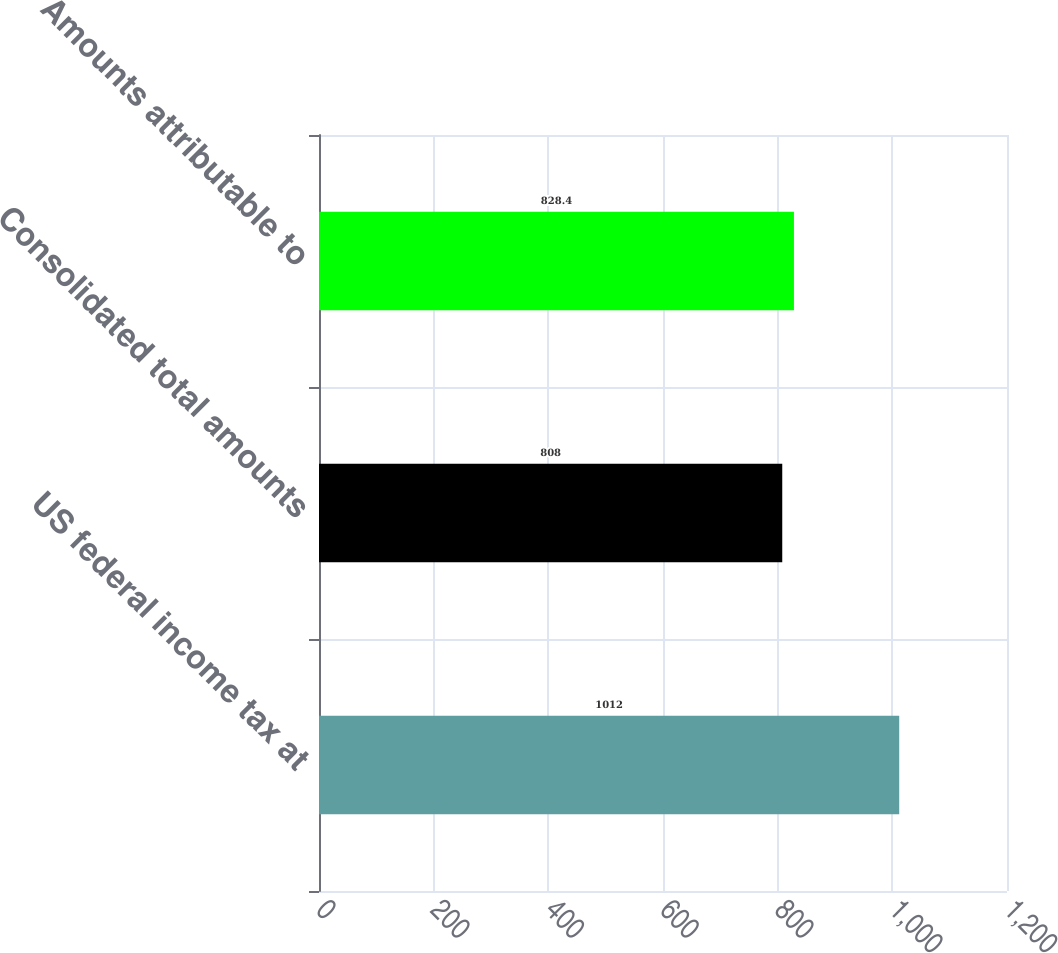Convert chart. <chart><loc_0><loc_0><loc_500><loc_500><bar_chart><fcel>US federal income tax at<fcel>Consolidated total amounts<fcel>Amounts attributable to<nl><fcel>1012<fcel>808<fcel>828.4<nl></chart> 